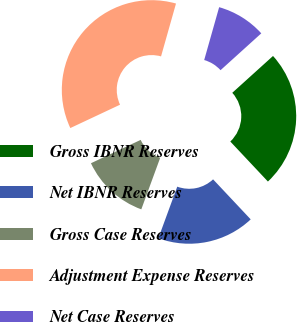<chart> <loc_0><loc_0><loc_500><loc_500><pie_chart><fcel>Gross IBNR Reserves<fcel>Net IBNR Reserves<fcel>Gross Case Reserves<fcel>Adjustment Expense Reserves<fcel>Net Case Reserves<nl><fcel>24.69%<fcel>17.6%<fcel>12.42%<fcel>36.38%<fcel>8.91%<nl></chart> 